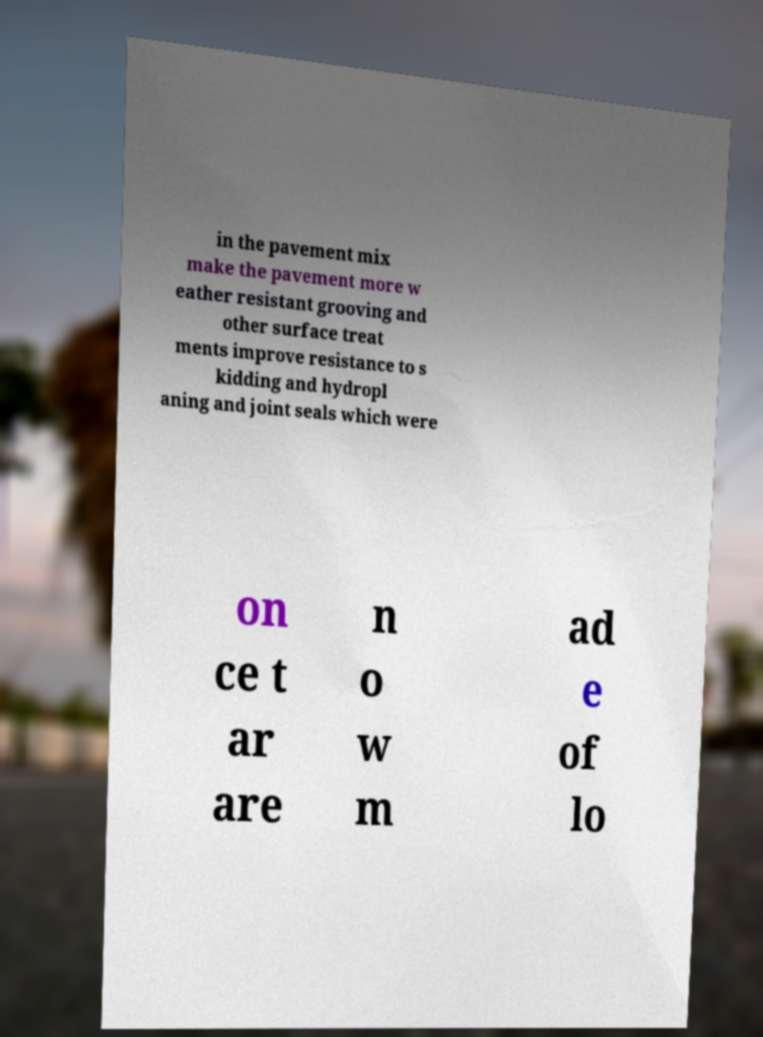Can you accurately transcribe the text from the provided image for me? in the pavement mix make the pavement more w eather resistant grooving and other surface treat ments improve resistance to s kidding and hydropl aning and joint seals which were on ce t ar are n o w m ad e of lo 